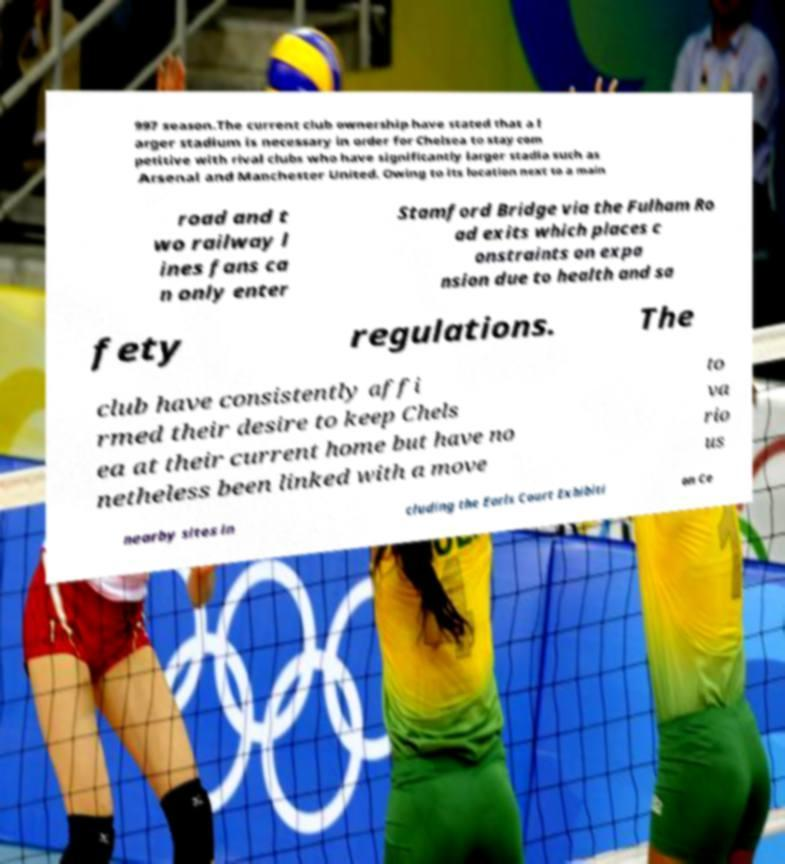For documentation purposes, I need the text within this image transcribed. Could you provide that? 997 season.The current club ownership have stated that a l arger stadium is necessary in order for Chelsea to stay com petitive with rival clubs who have significantly larger stadia such as Arsenal and Manchester United. Owing to its location next to a main road and t wo railway l ines fans ca n only enter Stamford Bridge via the Fulham Ro ad exits which places c onstraints on expa nsion due to health and sa fety regulations. The club have consistently affi rmed their desire to keep Chels ea at their current home but have no netheless been linked with a move to va rio us nearby sites in cluding the Earls Court Exhibiti on Ce 